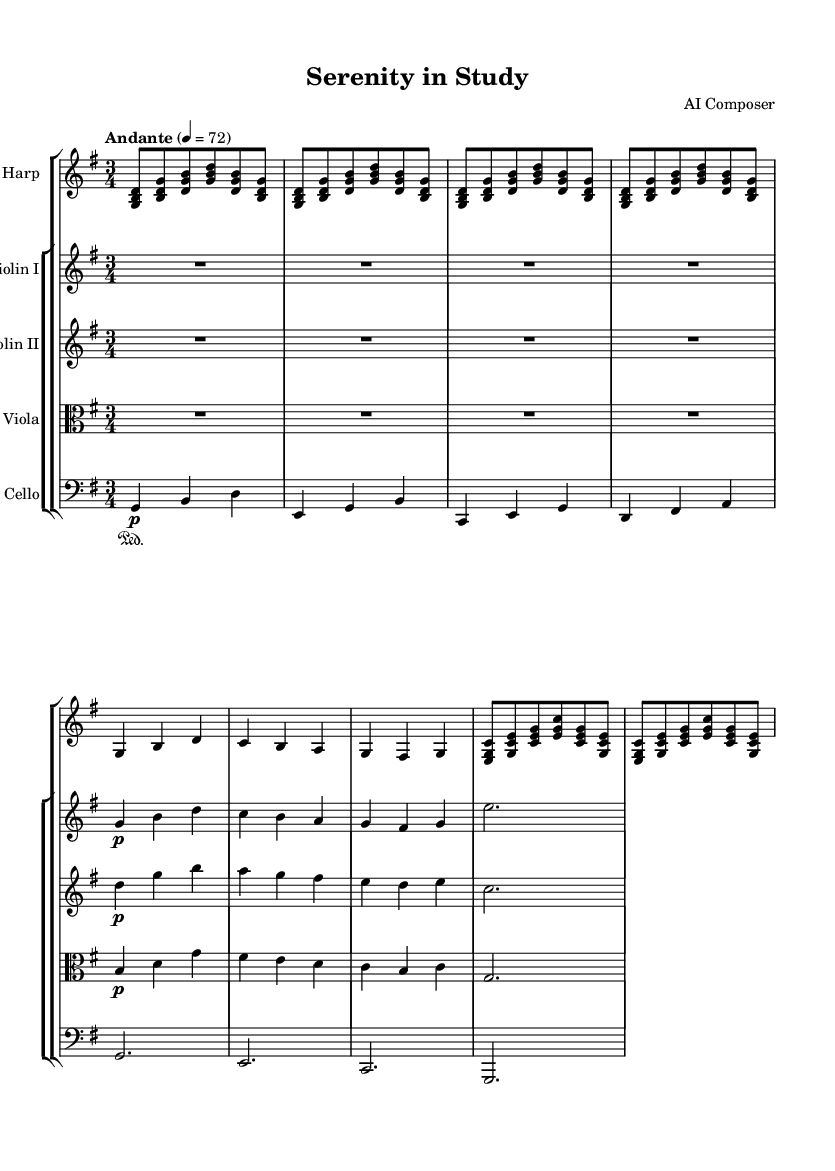What is the key signature of this music? The key signature is G major, which has one sharp (F#). This can be seen at the beginning of the staff indicated by the sharp symbol placed on the F line.
Answer: G major What is the time signature of the piece? The time signature is 3/4, which can be identified from the numbers located at the beginning of the score, indicating three beats per measure and a quarter note gets one beat.
Answer: 3/4 What tempo marking is given for this piece? The tempo marking is "Andante," which indicates a moderately slow tempo, generally around 76 to 108 beats per minute. This is noted above the staff at the beginning of the piece.
Answer: Andante How many measures are there in the harp part? The harp part contains 14 measures, as counted from the beginning to the end of the harp section including both the repeated sections and the initial measures.
Answer: 14 Which instruments are included in the string ensemble? The string ensemble includes Violin I, Violin II, Viola, and Cello, as indicated by their respective staff labels along the left side of the score.
Answer: Violin I, Violin II, Viola, Cello What dynamic marking is primarily used in this piece? The primary dynamic marking used throughout the piece is "p," which stands for "piano," indicating that the music should be played softly. This marking appears in several sections for individual parts.
Answer: p What is the total number of distinct sections in the string ensemble? There are four distinct sections in the string ensemble: one for each instrument (Violin I, Violin II, Viola, and Cello), which are grouped together in the score.
Answer: Four 